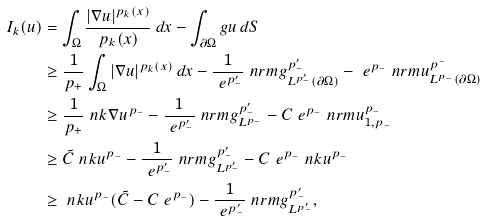<formula> <loc_0><loc_0><loc_500><loc_500>I _ { k } ( u ) & = \int _ { \Omega } \frac { | \nabla u | ^ { p _ { k } ( x ) } } { p _ { k } ( x ) } \, d x - \int _ { \partial \Omega } g u \, d S \\ & \geq \frac { 1 } { p _ { + } } \int _ { \Omega } | \nabla u | ^ { p _ { k } ( x ) } \, d x - \frac { 1 } { \ e ^ { p _ { - } ^ { \prime } } } \ n r m { g } _ { L ^ { p _ { - } ^ { \prime } } ( \partial \Omega ) } ^ { p _ { - } ^ { \prime } } - \ e ^ { p _ { - } } \ n r m { u } ^ { p ^ { - } } _ { L ^ { p _ { - } } ( \partial \Omega ) } \\ & \geq \frac { 1 } { p _ { + } } \ n k { \nabla u } ^ { p _ { - } } - \frac { 1 } { \ e ^ { p _ { - } ^ { \prime } } } \ n r m { g } _ { L ^ { p _ { - } } } ^ { p _ { - } ^ { \prime } } - C \ e ^ { p _ { - } } \ n r m { u } _ { 1 , { p _ { - } } } ^ { p _ { - } } \\ & \geq \tilde { C } \ n k { u } ^ { p _ { - } } - \frac { 1 } { \ e ^ { p _ { - } ^ { \prime } } } \ n r m { g } _ { L ^ { p _ { - } ^ { \prime } } } ^ { p _ { - } ^ { \prime } } - C \ e ^ { p _ { - } } \ n k { u } ^ { p _ { - } } \\ & \geq \ n k { u } ^ { p _ { - } } ( \tilde { C } - C \ e ^ { p _ { - } } ) - \frac { 1 } { \ e ^ { p _ { - } ^ { \prime } } } \ n r m { g } _ { L ^ { p _ { - } ^ { \prime } } } ^ { p _ { - } ^ { \prime } } ,</formula> 